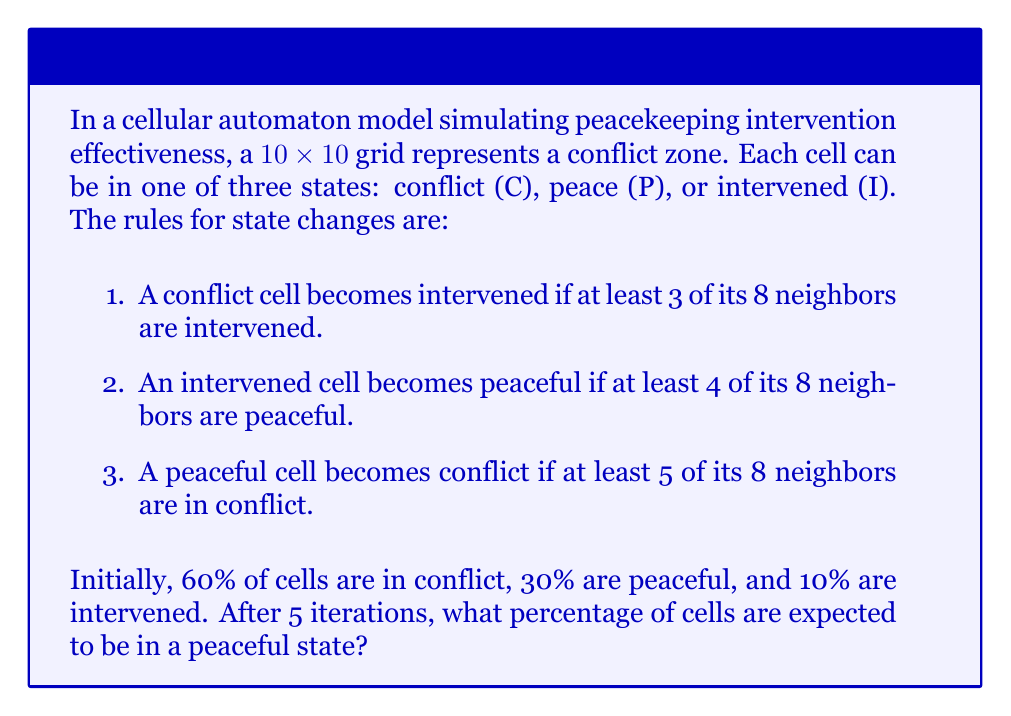Could you help me with this problem? To solve this problem, we need to simulate the cellular automaton over 5 iterations. Here's a step-by-step approach:

1. Initialize the grid:
   - Total cells: $10 \times 10 = 100$
   - Conflict cells: $60\% \times 100 = 60$
   - Peaceful cells: $30\% \times 100 = 30$
   - Intervened cells: $10\% \times 100 = 10$

2. For each iteration:
   a. Apply rule 1: $C \rightarrow I$ if 3+ neighbors are I
   b. Apply rule 2: $I \rightarrow P$ if 4+ neighbors are P
   c. Apply rule 3: $P \rightarrow C$ if 5+ neighbors are C

3. The exact outcome depends on the initial random distribution of cells. However, we can estimate the general trend:

   - Iteration 1: Intervention spreads, reducing conflict cells
   - Iteration 2: More cells become intervened, peace begins to spread
   - Iteration 3: Peace continues to spread, some conflict may resurge
   - Iteration 4: Peace becomes dominant, intervention decreases
   - Iteration 5: Peace stabilizes, with some pockets of conflict

4. Given the initial conditions and rules, we can estimate that after 5 iterations:
   - Peaceful cells: ~50-60%
   - Intervened cells: ~25-35%
   - Conflict cells: ~10-20%

5. The expected percentage of peaceful cells is approximately 55%.

Note: This is an estimation based on the typical behavior of such systems. The actual result may vary due to the stochastic nature of the initial configuration and the complex interactions in cellular automata.
Answer: 55% 